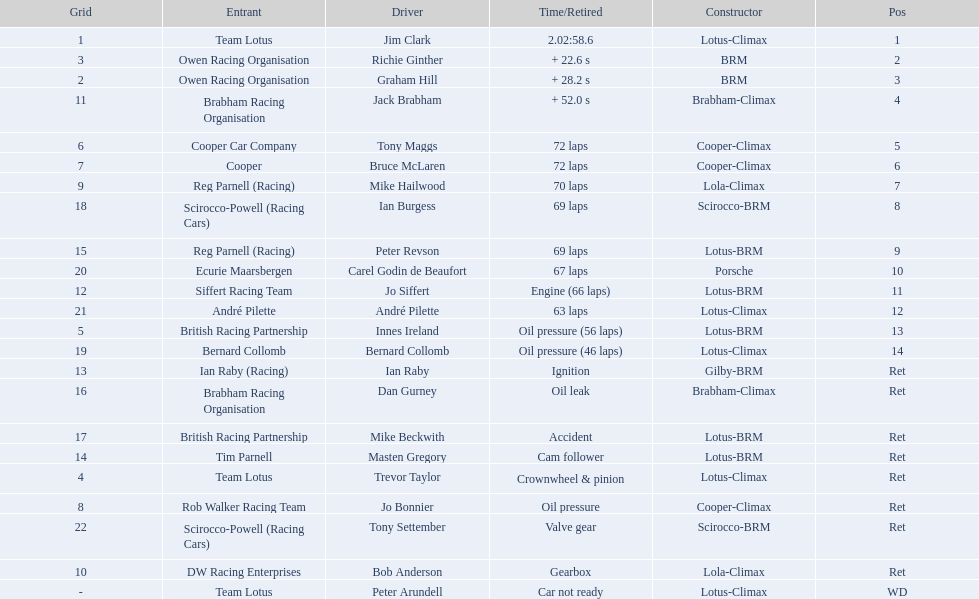Who are all the drivers? Jim Clark, Richie Ginther, Graham Hill, Jack Brabham, Tony Maggs, Bruce McLaren, Mike Hailwood, Ian Burgess, Peter Revson, Carel Godin de Beaufort, Jo Siffert, André Pilette, Innes Ireland, Bernard Collomb, Ian Raby, Dan Gurney, Mike Beckwith, Masten Gregory, Trevor Taylor, Jo Bonnier, Tony Settember, Bob Anderson, Peter Arundell. What position were they in? 1, 2, 3, 4, 5, 6, 7, 8, 9, 10, 11, 12, 13, 14, Ret, Ret, Ret, Ret, Ret, Ret, Ret, Ret, WD. What about just tony maggs and jo siffert? 5, 11. And between them, which driver came in earlier? Tony Maggs. 